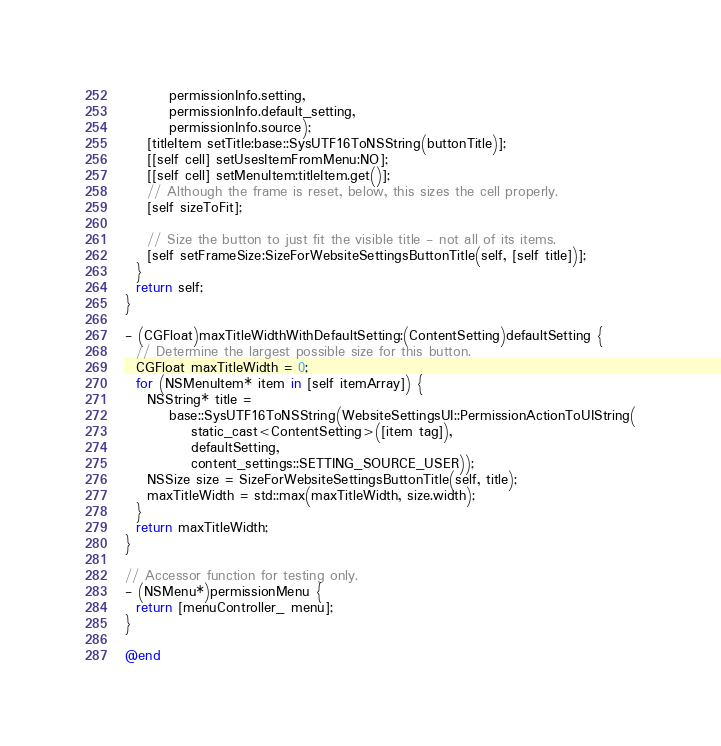<code> <loc_0><loc_0><loc_500><loc_500><_ObjectiveC_>        permissionInfo.setting,
        permissionInfo.default_setting,
        permissionInfo.source);
    [titleItem setTitle:base::SysUTF16ToNSString(buttonTitle)];
    [[self cell] setUsesItemFromMenu:NO];
    [[self cell] setMenuItem:titleItem.get()];
    // Although the frame is reset, below, this sizes the cell properly.
    [self sizeToFit];

    // Size the button to just fit the visible title - not all of its items.
    [self setFrameSize:SizeForWebsiteSettingsButtonTitle(self, [self title])];
  }
  return self;
}

- (CGFloat)maxTitleWidthWithDefaultSetting:(ContentSetting)defaultSetting {
  // Determine the largest possible size for this button.
  CGFloat maxTitleWidth = 0;
  for (NSMenuItem* item in [self itemArray]) {
    NSString* title =
        base::SysUTF16ToNSString(WebsiteSettingsUI::PermissionActionToUIString(
            static_cast<ContentSetting>([item tag]),
            defaultSetting,
            content_settings::SETTING_SOURCE_USER));
    NSSize size = SizeForWebsiteSettingsButtonTitle(self, title);
    maxTitleWidth = std::max(maxTitleWidth, size.width);
  }
  return maxTitleWidth;
}

// Accessor function for testing only.
- (NSMenu*)permissionMenu {
  return [menuController_ menu];
}

@end
</code> 